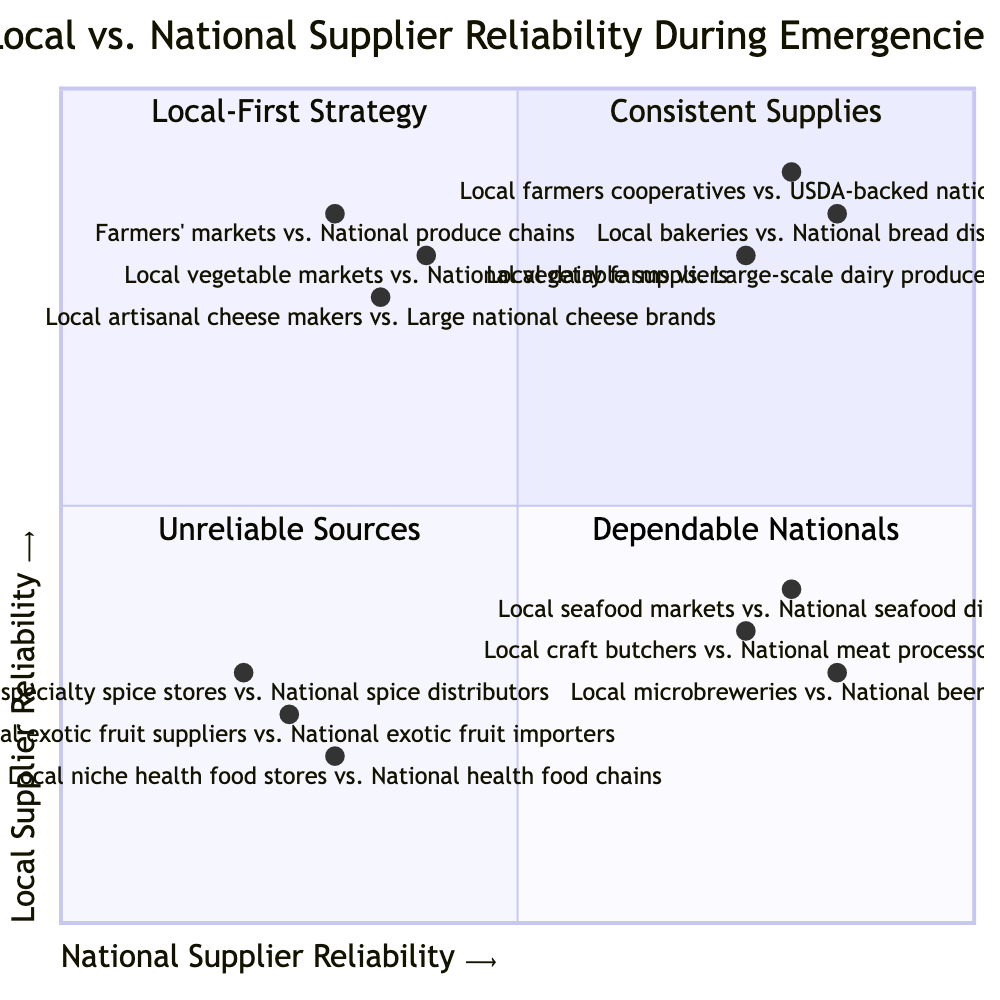What quadrant does local bakeries vs. national bread distributors fall into? By locating the reliability values on the x-axis and y-axis for local bakeries (0.85) and national bread distributors (0.85), both values are high, placing this pair in the "Consistent Supplies" quadrant.
Answer: Consistent Supplies How many examples are in the "Local-First Strategy" quadrant? The "Local-First Strategy" quadrant features three examples: Local vegetable markets vs. National vegetable suppliers, Farmers' markets vs. National produce chains, and Local artisanal cheese makers vs. Large national cheese brands. Counting these gives a total of three examples.
Answer: 3 Which supplier type is described as maintaining reliability during emergencies while national suppliers might falter? This description refers to the suppliers in the "Local-First Strategy" quadrant. This is because the quadrant indicates a scenario where local suppliers are reliable, but national ones may not be as dependable.
Answer: Local-First Strategy What is the reliability value for local microbreweries compared to national beer companies? The reliability value for local microbreweries is 0.85 on the y-axis, and for national beer companies, it is 0.3 on the x-axis. This shows that local microbreweries have a higher reliability value compared to national beer companies.
Answer: 0.85 Which quadrant contains examples of both local and national suppliers being unreliable? The quadrant labeled "Unreliable Sources" contains examples where both local special spice stores and national spice distributors are unreliable during emergencies.
Answer: Unreliable Sources What is the reliability of local seafood markets? The value for local seafood markets is found on the y-axis, which indicates a reliability score of 0.4. This reflects a relatively low reliability for local seafood markets in emergencies.
Answer: 0.4 What quadrant do local farmers cooperatives and USDA-backed national suppliers belong to? Both local farmers cooperatives and USDA-backed national suppliers have high reliability values (0.8 and 0.9 respectively), placing them in the "Consistent Supplies" quadrant.
Answer: Consistent Supplies How does the reliability of local dairy farms compare to large-scale dairy producers? The reliability for local dairy farms is 0.75 on the y-axis while large-scale dairy producers have a value of 0.8 on the x-axis. This indicates that local dairy farms have slightly lower reliability compared to the national suppliers.
Answer: 0.75 What is the main characteristic of the "Dependable Nationals" quadrant? The main characteristic is that national suppliers ensure reliability even when local suppliers cannot, as evidenced by examples like local seafood markets versus national seafood distributors.
Answer: National supplier reliability 